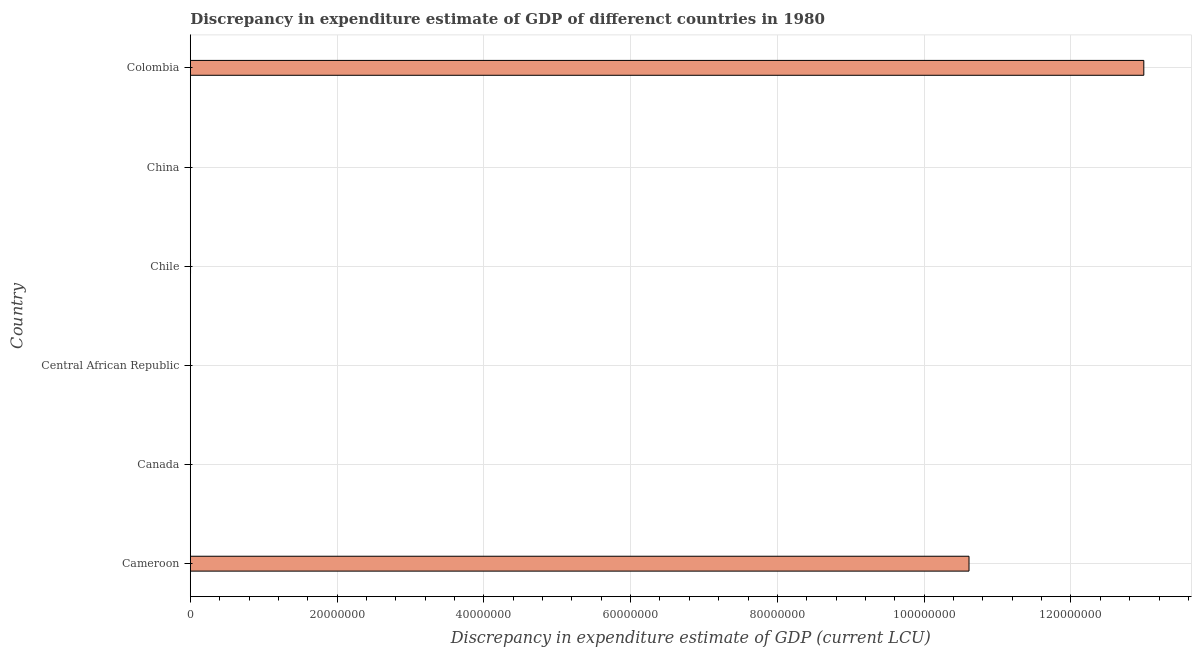Does the graph contain grids?
Give a very brief answer. Yes. What is the title of the graph?
Your response must be concise. Discrepancy in expenditure estimate of GDP of differenct countries in 1980. What is the label or title of the X-axis?
Your answer should be very brief. Discrepancy in expenditure estimate of GDP (current LCU). What is the discrepancy in expenditure estimate of gdp in Central African Republic?
Give a very brief answer. 2e-6. Across all countries, what is the maximum discrepancy in expenditure estimate of gdp?
Your answer should be very brief. 1.30e+08. Across all countries, what is the minimum discrepancy in expenditure estimate of gdp?
Provide a short and direct response. 0. What is the sum of the discrepancy in expenditure estimate of gdp?
Provide a succinct answer. 2.36e+08. What is the difference between the discrepancy in expenditure estimate of gdp in Cameroon and Chile?
Your response must be concise. 1.06e+08. What is the average discrepancy in expenditure estimate of gdp per country?
Give a very brief answer. 3.93e+07. What is the median discrepancy in expenditure estimate of gdp?
Your answer should be very brief. 1.64e+04. What is the difference between the highest and the second highest discrepancy in expenditure estimate of gdp?
Ensure brevity in your answer.  2.38e+07. Is the sum of the discrepancy in expenditure estimate of gdp in Chile and Colombia greater than the maximum discrepancy in expenditure estimate of gdp across all countries?
Provide a succinct answer. Yes. What is the difference between the highest and the lowest discrepancy in expenditure estimate of gdp?
Your answer should be very brief. 1.30e+08. In how many countries, is the discrepancy in expenditure estimate of gdp greater than the average discrepancy in expenditure estimate of gdp taken over all countries?
Your answer should be compact. 2. How many bars are there?
Offer a terse response. 4. Are all the bars in the graph horizontal?
Make the answer very short. Yes. How many countries are there in the graph?
Provide a succinct answer. 6. What is the difference between two consecutive major ticks on the X-axis?
Give a very brief answer. 2.00e+07. What is the Discrepancy in expenditure estimate of GDP (current LCU) in Cameroon?
Ensure brevity in your answer.  1.06e+08. What is the Discrepancy in expenditure estimate of GDP (current LCU) of Canada?
Provide a short and direct response. 0. What is the Discrepancy in expenditure estimate of GDP (current LCU) in Central African Republic?
Ensure brevity in your answer.  2e-6. What is the Discrepancy in expenditure estimate of GDP (current LCU) of Chile?
Provide a succinct answer. 3.27e+04. What is the Discrepancy in expenditure estimate of GDP (current LCU) in Colombia?
Your answer should be compact. 1.30e+08. What is the difference between the Discrepancy in expenditure estimate of GDP (current LCU) in Cameroon and Central African Republic?
Ensure brevity in your answer.  1.06e+08. What is the difference between the Discrepancy in expenditure estimate of GDP (current LCU) in Cameroon and Chile?
Your answer should be compact. 1.06e+08. What is the difference between the Discrepancy in expenditure estimate of GDP (current LCU) in Cameroon and Colombia?
Ensure brevity in your answer.  -2.38e+07. What is the difference between the Discrepancy in expenditure estimate of GDP (current LCU) in Central African Republic and Chile?
Provide a succinct answer. -3.27e+04. What is the difference between the Discrepancy in expenditure estimate of GDP (current LCU) in Central African Republic and Colombia?
Your answer should be very brief. -1.30e+08. What is the difference between the Discrepancy in expenditure estimate of GDP (current LCU) in Chile and Colombia?
Give a very brief answer. -1.30e+08. What is the ratio of the Discrepancy in expenditure estimate of GDP (current LCU) in Cameroon to that in Central African Republic?
Provide a short and direct response. 5.31e+13. What is the ratio of the Discrepancy in expenditure estimate of GDP (current LCU) in Cameroon to that in Chile?
Your response must be concise. 3244.99. What is the ratio of the Discrepancy in expenditure estimate of GDP (current LCU) in Cameroon to that in Colombia?
Make the answer very short. 0.82. What is the ratio of the Discrepancy in expenditure estimate of GDP (current LCU) in Central African Republic to that in Chile?
Make the answer very short. 0. 